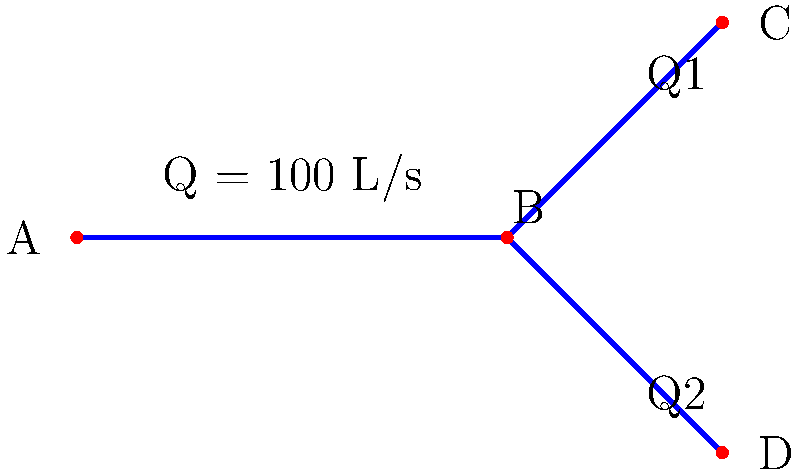In the pipe system shown, water flows from junction A to junctions C and D through junction B. The total flow rate at A is 100 L/s. If the flow rate at C (Q1) is 40% of the total flow, what is the flow rate at D (Q2) in L/s? To solve this problem, we'll follow these steps:

1. Identify the total flow rate:
   Total flow rate (Q) = 100 L/s

2. Calculate the flow rate at junction C (Q1):
   Q1 = 40% of total flow
   Q1 = 0.40 × 100 L/s = 40 L/s

3. Apply the principle of conservation of mass:
   The total inflow must equal the total outflow at junction B.
   Q = Q1 + Q2

4. Solve for Q2:
   100 L/s = 40 L/s + Q2
   Q2 = 100 L/s - 40 L/s
   Q2 = 60 L/s

Therefore, the flow rate at junction D (Q2) is 60 L/s.
Answer: 60 L/s 